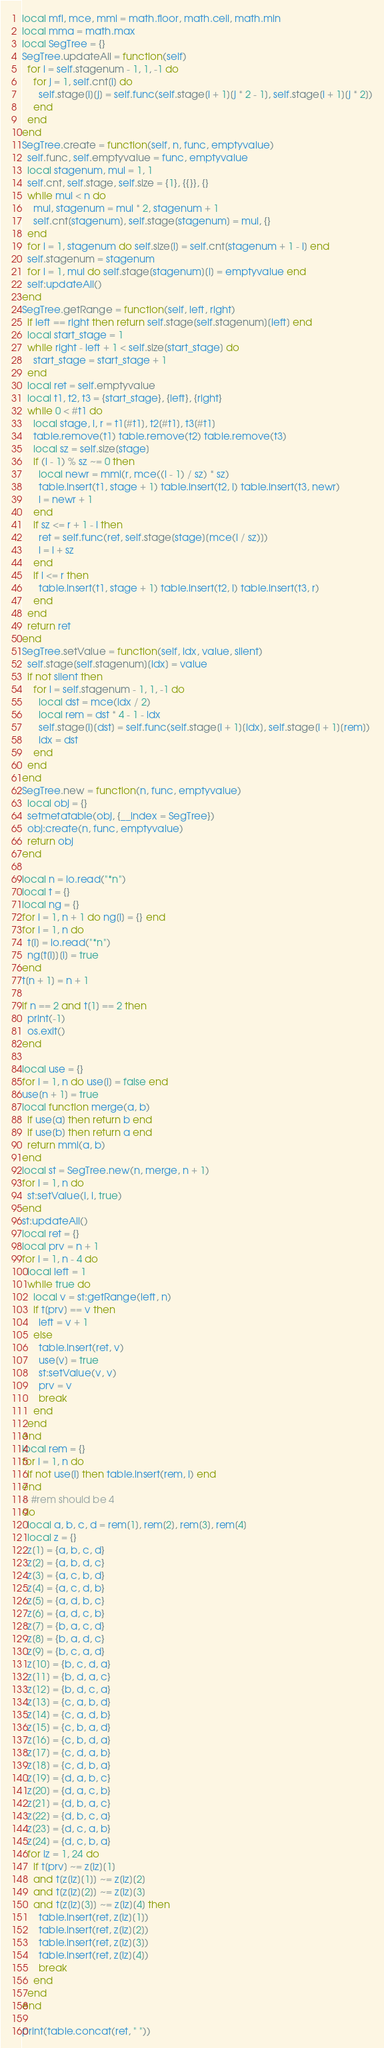Convert code to text. <code><loc_0><loc_0><loc_500><loc_500><_Lua_>local mfl, mce, mmi = math.floor, math.ceil, math.min
local mma = math.max
local SegTree = {}
SegTree.updateAll = function(self)
  for i = self.stagenum - 1, 1, -1 do
    for j = 1, self.cnt[i] do
      self.stage[i][j] = self.func(self.stage[i + 1][j * 2 - 1], self.stage[i + 1][j * 2])
    end
  end
end
SegTree.create = function(self, n, func, emptyvalue)
  self.func, self.emptyvalue = func, emptyvalue
  local stagenum, mul = 1, 1
  self.cnt, self.stage, self.size = {1}, {{}}, {}
  while mul < n do
    mul, stagenum = mul * 2, stagenum + 1
    self.cnt[stagenum], self.stage[stagenum] = mul, {}
  end
  for i = 1, stagenum do self.size[i] = self.cnt[stagenum + 1 - i] end
  self.stagenum = stagenum
  for i = 1, mul do self.stage[stagenum][i] = emptyvalue end
  self:updateAll()
end
SegTree.getRange = function(self, left, right)
  if left == right then return self.stage[self.stagenum][left] end
  local start_stage = 1
  while right - left + 1 < self.size[start_stage] do
    start_stage = start_stage + 1
  end
  local ret = self.emptyvalue
  local t1, t2, t3 = {start_stage}, {left}, {right}
  while 0 < #t1 do
    local stage, l, r = t1[#t1], t2[#t1], t3[#t1]
    table.remove(t1) table.remove(t2) table.remove(t3)
    local sz = self.size[stage]
    if (l - 1) % sz ~= 0 then
      local newr = mmi(r, mce((l - 1) / sz) * sz)
      table.insert(t1, stage + 1) table.insert(t2, l) table.insert(t3, newr)
      l = newr + 1
    end
    if sz <= r + 1 - l then
      ret = self.func(ret, self.stage[stage][mce(l / sz)])
      l = l + sz
    end
    if l <= r then
      table.insert(t1, stage + 1) table.insert(t2, l) table.insert(t3, r)
    end
  end
  return ret
end
SegTree.setValue = function(self, idx, value, silent)
  self.stage[self.stagenum][idx] = value
  if not silent then
    for i = self.stagenum - 1, 1, -1 do
      local dst = mce(idx / 2)
      local rem = dst * 4 - 1 - idx
      self.stage[i][dst] = self.func(self.stage[i + 1][idx], self.stage[i + 1][rem])
      idx = dst
    end
  end
end
SegTree.new = function(n, func, emptyvalue)
  local obj = {}
  setmetatable(obj, {__index = SegTree})
  obj:create(n, func, emptyvalue)
  return obj
end

local n = io.read("*n")
local t = {}
local ng = {}
for i = 1, n + 1 do ng[i] = {} end
for i = 1, n do
  t[i] = io.read("*n")
  ng[t[i]][i] = true
end
t[n + 1] = n + 1

if n == 2 and t[1] == 2 then
  print(-1)
  os.exit()
end

local use = {}
for i = 1, n do use[i] = false end
use[n + 1] = true
local function merge(a, b)
  if use[a] then return b end
  if use[b] then return a end
  return mmi(a, b)
end
local st = SegTree.new(n, merge, n + 1)
for i = 1, n do
  st:setValue(i, i, true)
end
st:updateAll()
local ret = {}
local prv = n + 1
for i = 1, n - 4 do
  local left = 1
  while true do
    local v = st:getRange(left, n)
    if t[prv] == v then
      left = v + 1
    else
      table.insert(ret, v)
      use[v] = true
      st:setValue(v, v)
      prv = v
      break
    end
  end
end
local rem = {}
for i = 1, n do
  if not use[i] then table.insert(rem, i) end
end
-- #rem should be 4
do
  local a, b, c, d = rem[1], rem[2], rem[3], rem[4]
  local z = {}
  z[1] = {a, b, c, d}
  z[2] = {a, b, d, c}
  z[3] = {a, c, b, d}
  z[4] = {a, c, d, b}
  z[5] = {a, d, b, c}
  z[6] = {a, d, c, b}
  z[7] = {b, a, c, d}
  z[8] = {b, a, d, c}
  z[9] = {b, c, a, d}
  z[10] = {b, c, d, a}
  z[11] = {b, d, a, c}
  z[12] = {b, d, c, a}
  z[13] = {c, a, b, d}
  z[14] = {c, a, d, b}
  z[15] = {c, b, a, d}
  z[16] = {c, b, d, a}
  z[17] = {c, d, a, b}
  z[18] = {c, d, b, a}
  z[19] = {d, a, b, c}
  z[20] = {d, a, c, b}
  z[21] = {d, b, a, c}
  z[22] = {d, b, c, a}
  z[23] = {d, c, a, b}
  z[24] = {d, c, b, a}
  for iz = 1, 24 do
    if t[prv] ~= z[iz][1]
    and t[z[iz][1]] ~= z[iz][2]
    and t[z[iz][2]] ~= z[iz][3]
    and t[z[iz][3]] ~= z[iz][4] then
      table.insert(ret, z[iz][1])
      table.insert(ret, z[iz][2])
      table.insert(ret, z[iz][3])
      table.insert(ret, z[iz][4])
      break
    end
  end
end

print(table.concat(ret, " "))
</code> 